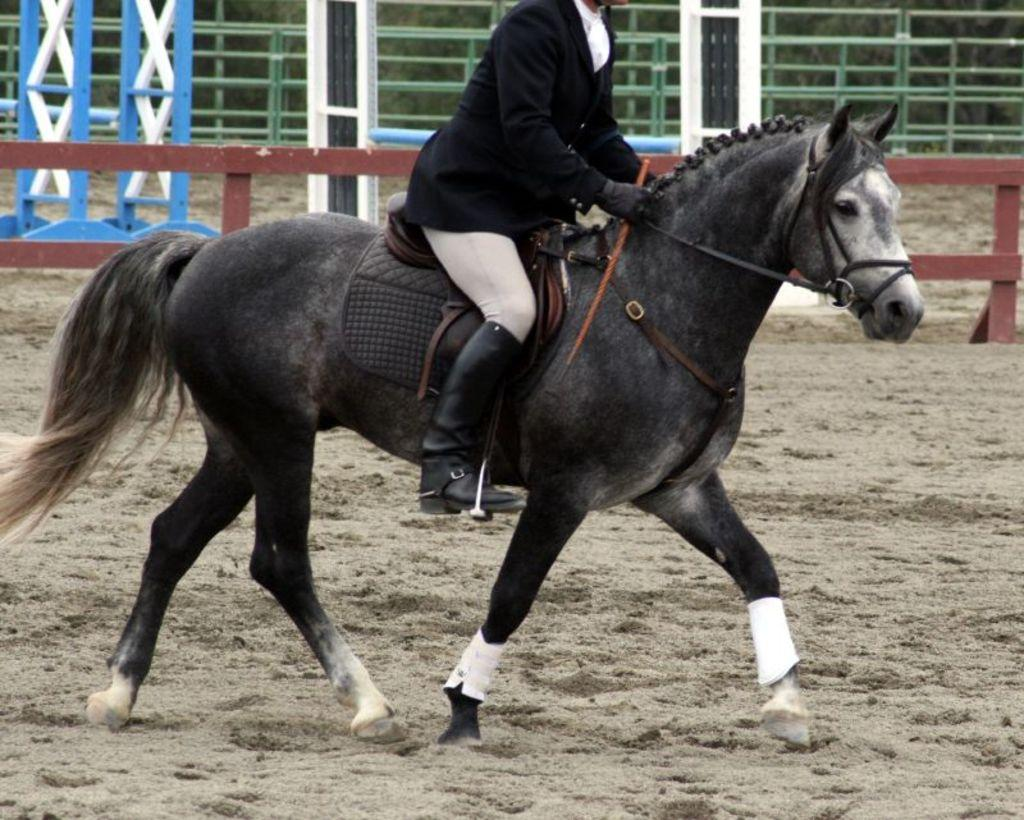What is the person doing in the image? The person is sitting on a horse in the image. What color is the horse? The horse is black in color. What can be seen in the background of the image? There is railing visible in the background of the image. What type of cap is the horse wearing in the image? There is no cap present on the horse in the image. What kind of jewel can be seen on the person's hand in the image? There is no jewel visible on the person's hand in the image. 